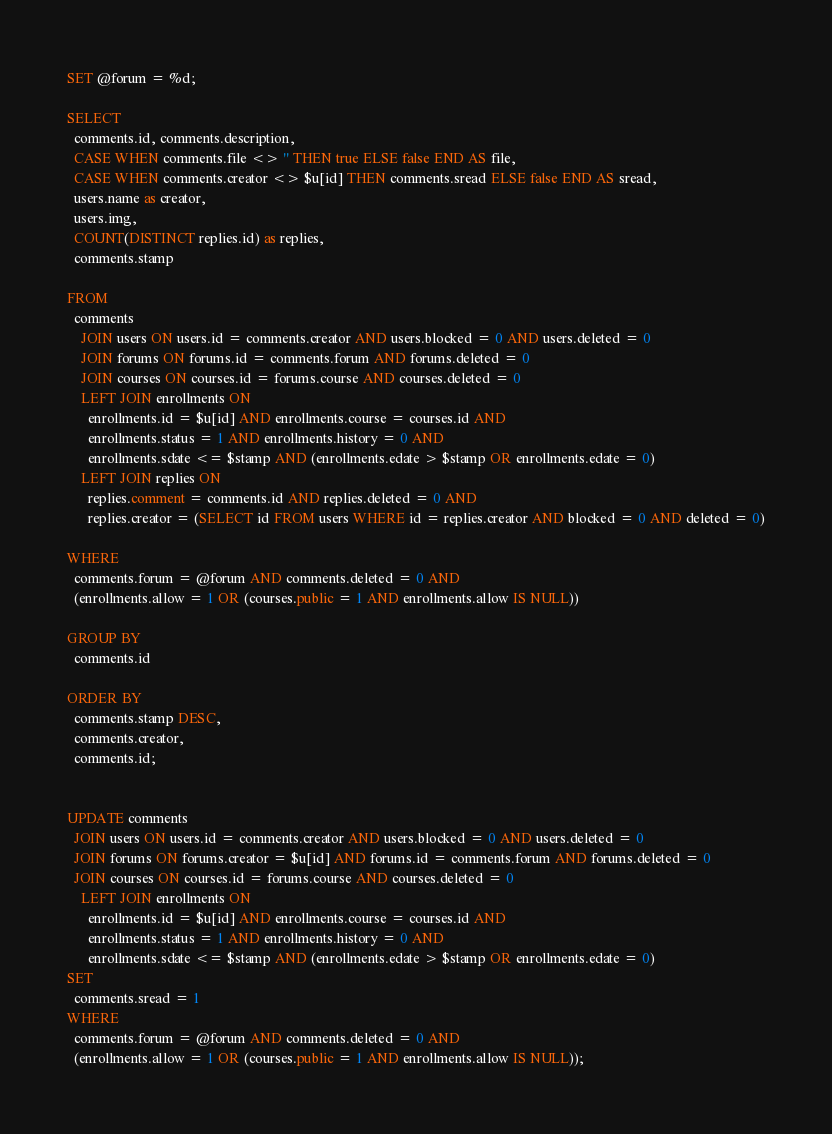<code> <loc_0><loc_0><loc_500><loc_500><_SQL_>
SET @forum = %d;

SELECT
  comments.id, comments.description,
  CASE WHEN comments.file <> '' THEN true ELSE false END AS file,
  CASE WHEN comments.creator <> $u[id] THEN comments.sread ELSE false END AS sread,
  users.name as creator,
  users.img,
  COUNT(DISTINCT replies.id) as replies,
  comments.stamp

FROM
  comments
    JOIN users ON users.id = comments.creator AND users.blocked = 0 AND users.deleted = 0
    JOIN forums ON forums.id = comments.forum AND forums.deleted = 0
    JOIN courses ON courses.id = forums.course AND courses.deleted = 0
    LEFT JOIN enrollments ON
      enrollments.id = $u[id] AND enrollments.course = courses.id AND
      enrollments.status = 1 AND enrollments.history = 0 AND
      enrollments.sdate <= $stamp AND (enrollments.edate > $stamp OR enrollments.edate = 0)
    LEFT JOIN replies ON
      replies.comment = comments.id AND replies.deleted = 0 AND
      replies.creator = (SELECT id FROM users WHERE id = replies.creator AND blocked = 0 AND deleted = 0)

WHERE
  comments.forum = @forum AND comments.deleted = 0 AND
  (enrollments.allow = 1 OR (courses.public = 1 AND enrollments.allow IS NULL))

GROUP BY
  comments.id

ORDER BY
  comments.stamp DESC,
  comments.creator,
  comments.id;


UPDATE comments
  JOIN users ON users.id = comments.creator AND users.blocked = 0 AND users.deleted = 0
  JOIN forums ON forums.creator = $u[id] AND forums.id = comments.forum AND forums.deleted = 0
  JOIN courses ON courses.id = forums.course AND courses.deleted = 0
    LEFT JOIN enrollments ON
      enrollments.id = $u[id] AND enrollments.course = courses.id AND
      enrollments.status = 1 AND enrollments.history = 0 AND
      enrollments.sdate <= $stamp AND (enrollments.edate > $stamp OR enrollments.edate = 0)
SET
  comments.sread = 1
WHERE
  comments.forum = @forum AND comments.deleted = 0 AND
  (enrollments.allow = 1 OR (courses.public = 1 AND enrollments.allow IS NULL));</code> 